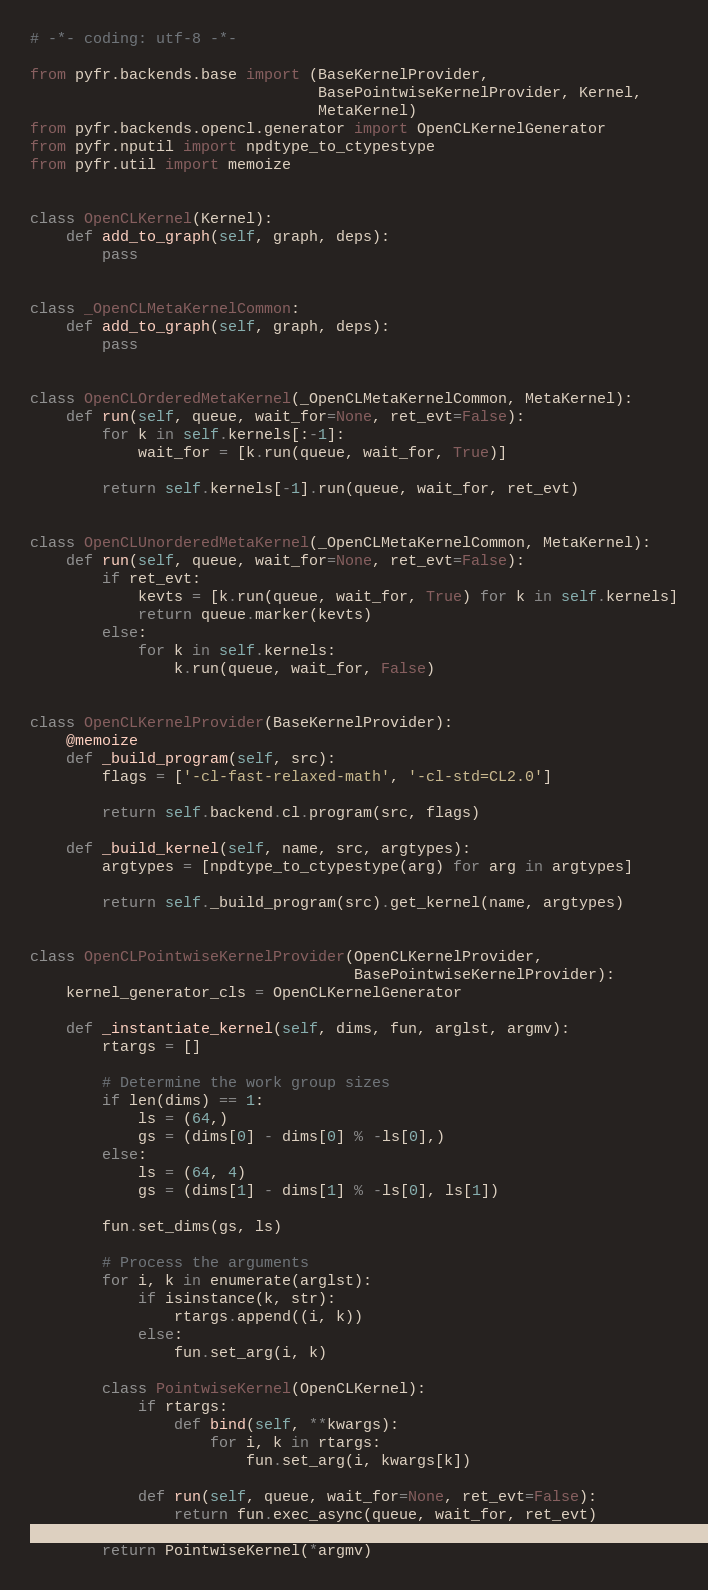<code> <loc_0><loc_0><loc_500><loc_500><_Python_># -*- coding: utf-8 -*-

from pyfr.backends.base import (BaseKernelProvider,
                                BasePointwiseKernelProvider, Kernel,
                                MetaKernel)
from pyfr.backends.opencl.generator import OpenCLKernelGenerator
from pyfr.nputil import npdtype_to_ctypestype
from pyfr.util import memoize


class OpenCLKernel(Kernel):
    def add_to_graph(self, graph, deps):
        pass


class _OpenCLMetaKernelCommon:
    def add_to_graph(self, graph, deps):
        pass


class OpenCLOrderedMetaKernel(_OpenCLMetaKernelCommon, MetaKernel):
    def run(self, queue, wait_for=None, ret_evt=False):
        for k in self.kernels[:-1]:
            wait_for = [k.run(queue, wait_for, True)]

        return self.kernels[-1].run(queue, wait_for, ret_evt)


class OpenCLUnorderedMetaKernel(_OpenCLMetaKernelCommon, MetaKernel):
    def run(self, queue, wait_for=None, ret_evt=False):
        if ret_evt:
            kevts = [k.run(queue, wait_for, True) for k in self.kernels]
            return queue.marker(kevts)
        else:
            for k in self.kernels:
                k.run(queue, wait_for, False)


class OpenCLKernelProvider(BaseKernelProvider):
    @memoize
    def _build_program(self, src):
        flags = ['-cl-fast-relaxed-math', '-cl-std=CL2.0']

        return self.backend.cl.program(src, flags)

    def _build_kernel(self, name, src, argtypes):
        argtypes = [npdtype_to_ctypestype(arg) for arg in argtypes]

        return self._build_program(src).get_kernel(name, argtypes)


class OpenCLPointwiseKernelProvider(OpenCLKernelProvider,
                                    BasePointwiseKernelProvider):
    kernel_generator_cls = OpenCLKernelGenerator

    def _instantiate_kernel(self, dims, fun, arglst, argmv):
        rtargs = []

        # Determine the work group sizes
        if len(dims) == 1:
            ls = (64,)
            gs = (dims[0] - dims[0] % -ls[0],)
        else:
            ls = (64, 4)
            gs = (dims[1] - dims[1] % -ls[0], ls[1])

        fun.set_dims(gs, ls)

        # Process the arguments
        for i, k in enumerate(arglst):
            if isinstance(k, str):
                rtargs.append((i, k))
            else:
                fun.set_arg(i, k)

        class PointwiseKernel(OpenCLKernel):
            if rtargs:
                def bind(self, **kwargs):
                    for i, k in rtargs:
                        fun.set_arg(i, kwargs[k])

            def run(self, queue, wait_for=None, ret_evt=False):
                return fun.exec_async(queue, wait_for, ret_evt)

        return PointwiseKernel(*argmv)
</code> 